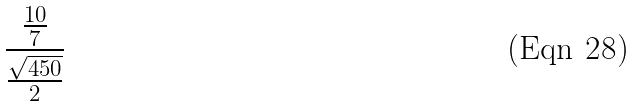Convert formula to latex. <formula><loc_0><loc_0><loc_500><loc_500>\frac { \frac { 1 0 } { 7 } } { \frac { \sqrt { 4 5 0 } } { 2 } }</formula> 